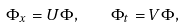Convert formula to latex. <formula><loc_0><loc_0><loc_500><loc_500>\Phi _ { x } = U \Phi , \quad \Phi _ { t } = V \Phi ,</formula> 